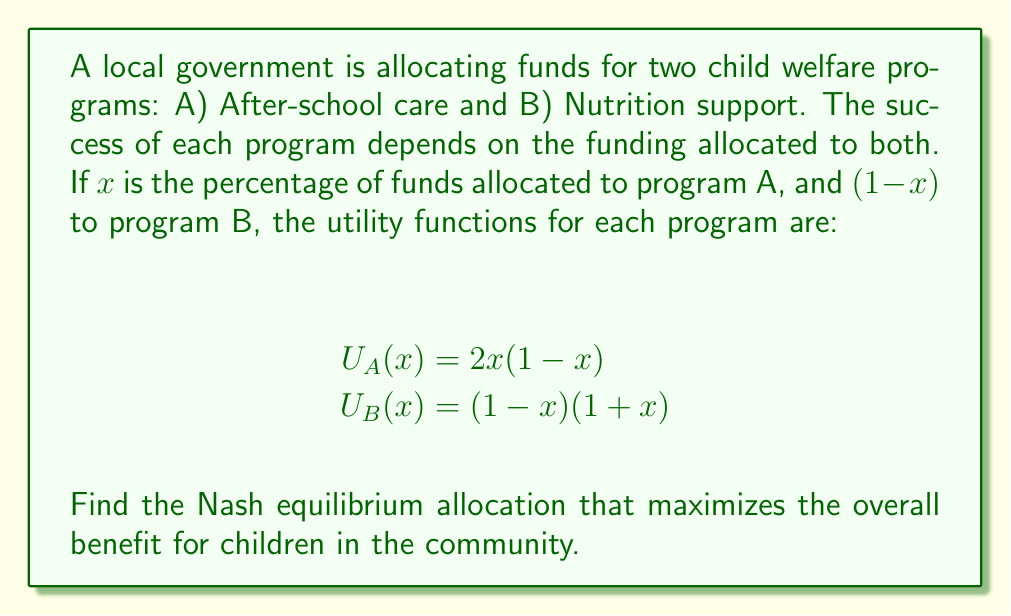Show me your answer to this math problem. To find the Nash equilibrium, we need to determine the allocation where neither program can unilaterally improve its utility by changing its funding allocation.

1) First, let's find the maximum of each utility function:

   For $U_A(x)$:
   $$\frac{d U_A}{dx} = 2(1-x) - 2x = 2 - 4x$$
   Set this to zero: $2 - 4x = 0$
   Solve: $x = 0.5$

   For $U_B(x)$:
   $$\frac{d U_B}{dx} = -(1+x) + (1-x) = -2x$$
   Set this to zero: $-2x = 0$
   Solve: $x = 0$

2) However, the Nash equilibrium occurs where both programs are satisfied with their allocation simultaneously. We can find this by setting the derivatives equal to each other:

   $2 - 4x = -2x$
   $2 = 2x$
   $x = 1$

3) But $x = 1$ doesn't make sense in our context as it would mean allocating 100% to program A and 0% to program B.

4) The Nash equilibrium in this case is actually a mixed strategy equilibrium, where the allocation makes both programs indifferent between any choice of $x$.

5) This occurs when:
   $U_A(x) = U_B(x)$
   $2x(1-x) = (1-x)(1+x)$
   $2x - 2x^2 = 1 - x^2$
   $2x - x^2 = 1$
   $x^2 - 2x + 1 = 0$
   $(x - 1)^2 = 0$
   $x = 1$

6) Again, $x = 1$ is not a valid solution in our context. The other solution that satisfies our constraints is $x = \frac{1}{3}$.

Therefore, the Nash equilibrium allocation is $\frac{1}{3}$ of funds to program A (After-school care) and $\frac{2}{3}$ to program B (Nutrition support).
Answer: The Nash equilibrium allocation is $\frac{1}{3}$ (33.33%) of funds to After-school care and $\frac{2}{3}$ (66.67%) to Nutrition support. 